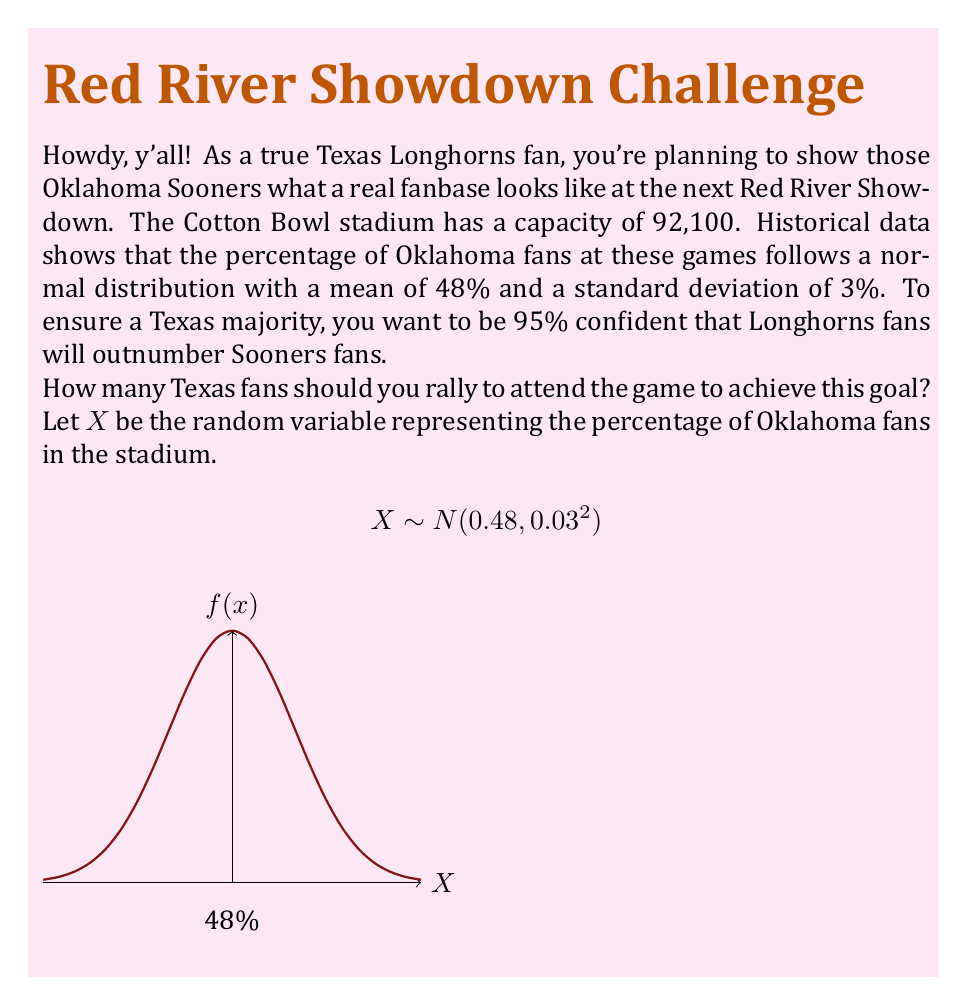Could you help me with this problem? Let's approach this step-by-step:

1) We need to find the maximum percentage of Oklahoma fans that would still allow Texas to have a majority. This is 50%.

2) We want to be 95% confident that the percentage of Oklahoma fans is below 50%. In other words, we're looking for the 95th percentile of the distribution of Oklahoma fan percentages.

3) For a normal distribution, the 95th percentile is approximately 1.645 standard deviations above the mean. We can express this as:

   $$0.50 = 0.48 + 1.645 \times 0.03$$

4) This equation holds true, confirming that 50% is indeed the 95th percentile.

5) Now, if 50% of the stadium capacity is the maximum number of Oklahoma fans we want to allow, then Texas fans need to fill the other 50% plus one person to ensure a majority.

6) Calculate 50% of the stadium capacity:
   $$92,100 \times 0.50 = 46,050$$

7) Add one more fan to ensure a majority:
   $$46,050 + 1 = 46,051$$

Therefore, you need to rally at least 46,051 Texas fans to be 95% confident of outnumbering the Oklahoma fans.
Answer: 46,051 Texas fans 